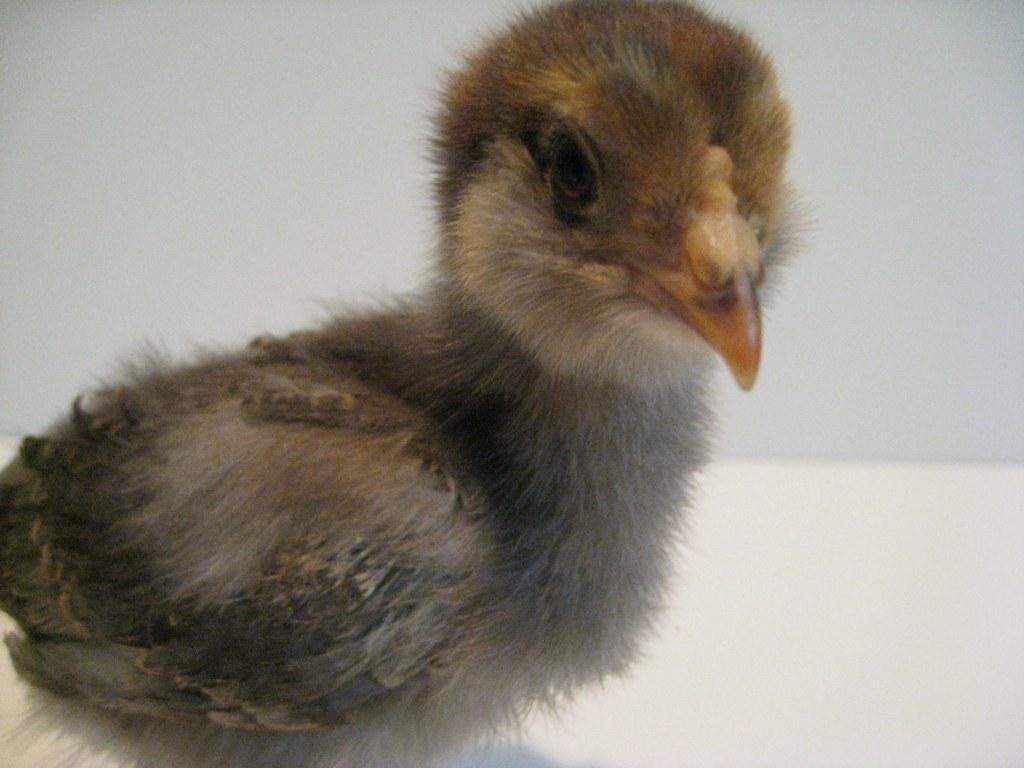What type of animal is present in the image? There is a duckling in the image. What color is the background of the image? The background of the image is white in color. What type of hook is being used to adjust the duckling's position in the image? There is no hook or adjustment visible in the image; it simply features a duckling against a white background. How many beans are present in the image? There are no beans present in the image. 